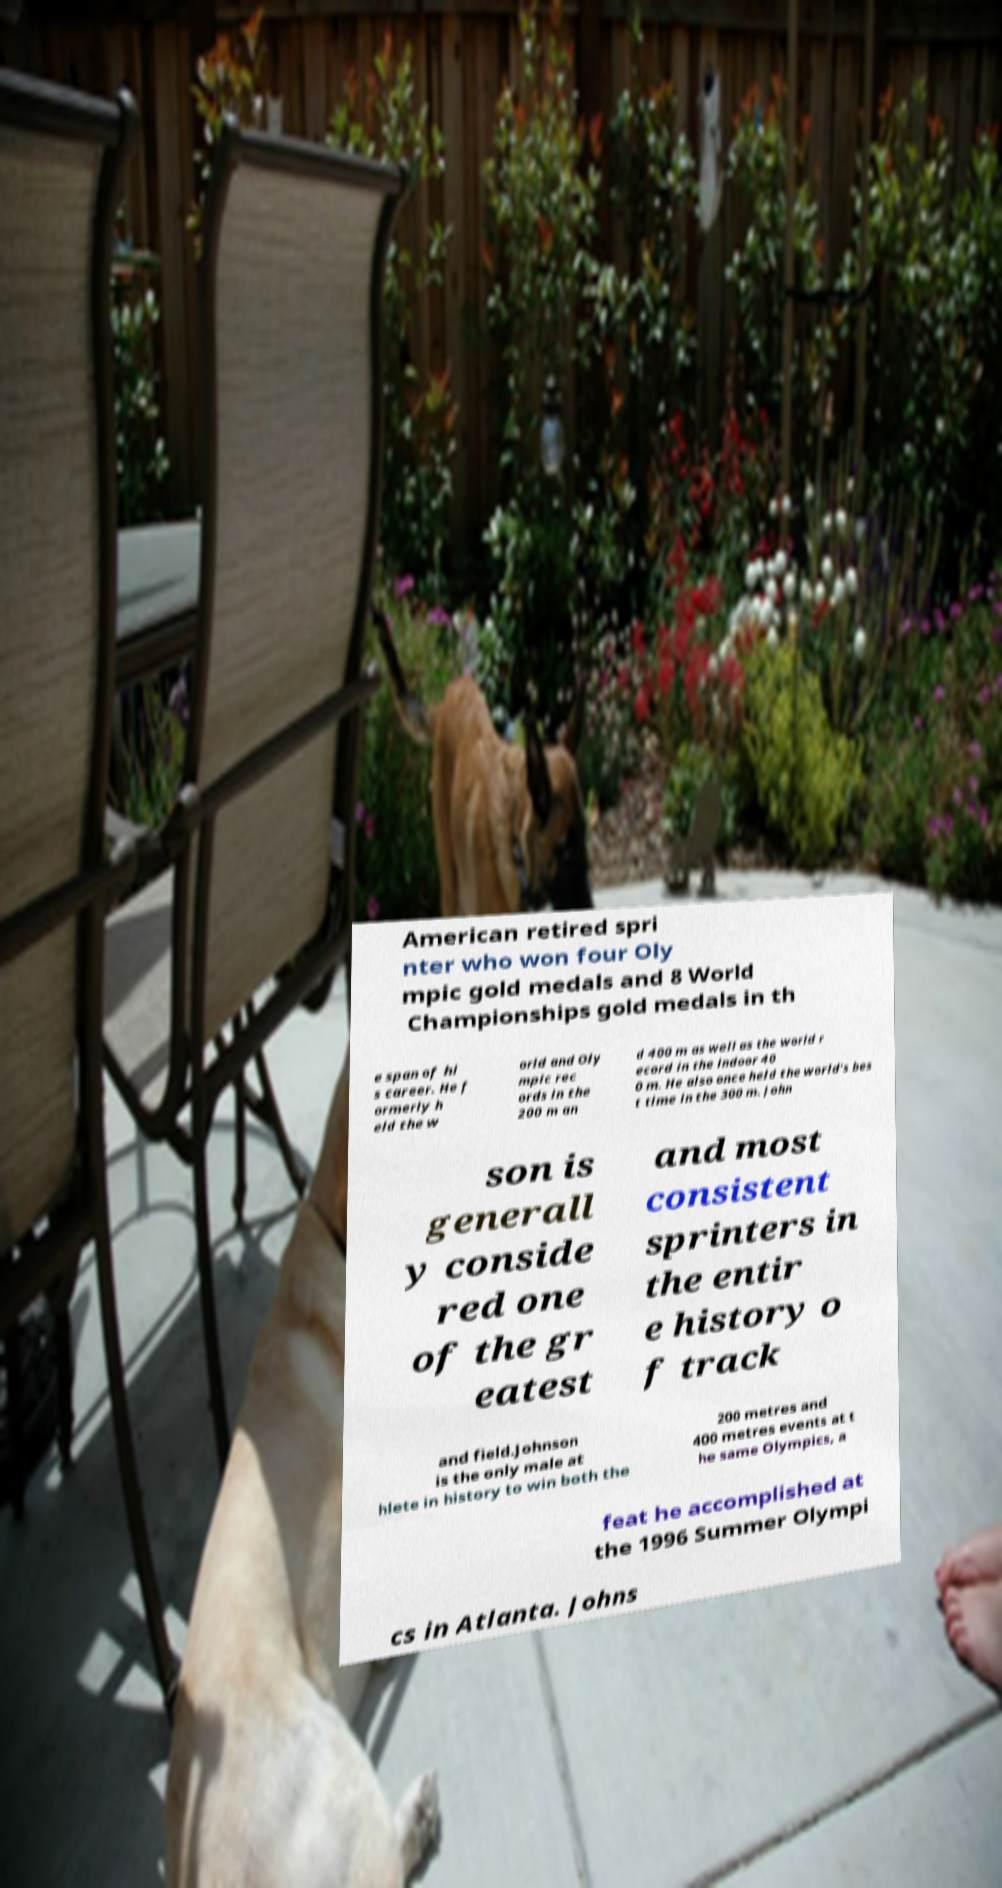Please read and relay the text visible in this image. What does it say? American retired spri nter who won four Oly mpic gold medals and 8 World Championships gold medals in th e span of hi s career. He f ormerly h eld the w orld and Oly mpic rec ords in the 200 m an d 400 m as well as the world r ecord in the indoor 40 0 m. He also once held the world's bes t time in the 300 m. John son is generall y conside red one of the gr eatest and most consistent sprinters in the entir e history o f track and field.Johnson is the only male at hlete in history to win both the 200 metres and 400 metres events at t he same Olympics, a feat he accomplished at the 1996 Summer Olympi cs in Atlanta. Johns 